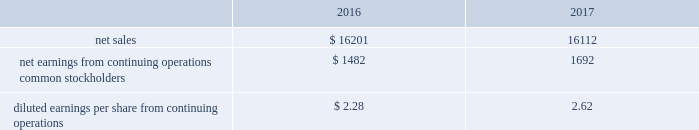Pro forma financial information the following pro forma consolidated condensed financial results of operations are presented as if the acquisition of the valves & controls business occurred on october 1 , 2015 .
The pro forma information is presented for informational purposes only and is not indicative of the results of operations that would have been achieved had the acquisition occurred as of that time. .
The pro forma results for 2016 were adjusted to include first year acquisition accounting charges related to inventory and backlog of $ 122 in 2017 .
The pro forma 2016 results also include acquisition costs of $ 52 , while the 2017 pro forma results were adjusted to exclude these charges .
On october 2 , 2017 , the company sold its residential storage business for $ 200 in cash , subject to post-closing adjustments , and expects to recognize a loss of approximately $ 40 in 2018 due to income taxes resulting from nondeductible goodwill .
The company expects to realize approximately $ 140 in after-tax cash proceeds from the sale .
This business , with sales of $ 298 and pretax earnings of $ 15 in 2017 , is a leader in home organization and storage systems , and was reported within the tools & home products segment .
Assets and liabilities were classified as held-for-sale as of september 30 , 2017 .
The company acquired six businesses in 2016 , four in automation solutions and two in climate technologies .
Total cash paid for these businesses was $ 132 , net of cash acquired .
Annualized sales for these businesses were approximately $ 51 in 2016 .
The company recognized goodwill of $ 83 ( $ 27 of which is expected to be tax deductible ) and other identifiable intangible assets of $ 50 , primarily customer relationships and intellectual property with a weighted-average life of approximately nine years .
The company completed eight acquisitions in 2015 , seven in automation solutions and one in tools & home products , which had combined annualized sales of approximately $ 115 .
Total cash paid for all businesses was $ 324 , net of cash acquired .
The company recognized goodwill of $ 178 ( $ 42 of which is expected to be tax deductible ) and other intangible assets of $ 128 , primarily customer relationships and intellectual property with a weighted-average life of approximately ten years .
In january 2015 , the company completed the sale of its mechanical power transmission solutions business for $ 1.4 billion , and recognized a pretax gain from the transaction of $ 939 ( $ 532 after-tax , $ 0.78 per share ) .
Assets and liabilities sold were as follows : current assets , $ 182 ( accounts receivable , inventories , other current assets ) ; other assets , $ 374 ( property , plant and equipment , goodwill , other noncurrent assets ) ; accrued expenses , $ 56 ( accounts payable , other current liabilities ) ; and other liabilities , $ 41 .
Proceeds from the divestiture were used for share repurchase .
This business was previously reported in the former industrial automation segment , and had partial year sales in 2015 of $ 189 and related pretax earnings of $ 21 .
Power transmission solutions designs and manufactures market-leading couplings , bearings , conveying components and gearing and drive components , and provides supporting services and solutions .
On september 30 , 2015 , the company sold its intermetro commercial storage business for $ 411 in cash and recognized a pretax gain from the transaction of $ 100 ( $ 79 after-tax , $ 0.12 per share ) .
This business had annual sales of $ 288 and pretax earnings of $ 42 in 2015 and was reported in the former commercial & residential solutions segment .
Assets and liabilities sold were as follows : current assets , $ 62 ( accounts receivable , inventories , other current assets ) ; other assets , $ 292 ( property , plant and equipment , goodwill , other noncurrent assets ) ; current liabilities , $ 34 ( accounts payable , other current liabilities ) ; and other liabilities , $ 9 .
Intermetro is a leading manufacturer and supplier of storage and transport products in the food service , commercial products and health care industries .
The results of operations of the acquired businesses discussed above have been included in the company 2019s consolidated results of operations since the respective dates of acquisition .
( 4 ) discontinued operations in 2017 , the company completed the previously announced strategic actions to streamline its portfolio and drive growth in its core businesses .
On november 30 , 2016 , the company completed the sale of its network power systems business for $ 4.0 billion in cash and retained a subordinated interest in distributions , contingent upon the equity holders first receiving a threshold return on their initial investment .
This business comprised the former network power segment .
Additionally , on january 31 , 2017 , the company completed the sale of its power generation , motors and drives business for approximately $ 1.2 billion , subject to post-closing .
What was the percentage change on pro forma basis of the diluted earnings per share from continuing operations between 2016 and 2017? 
Rationale: this lets us get a read on the impact of the additional business to earnings per share , even with the sales decline .
Computations: ((2.62 - 2.28) / 2.28)
Answer: 0.14912. 